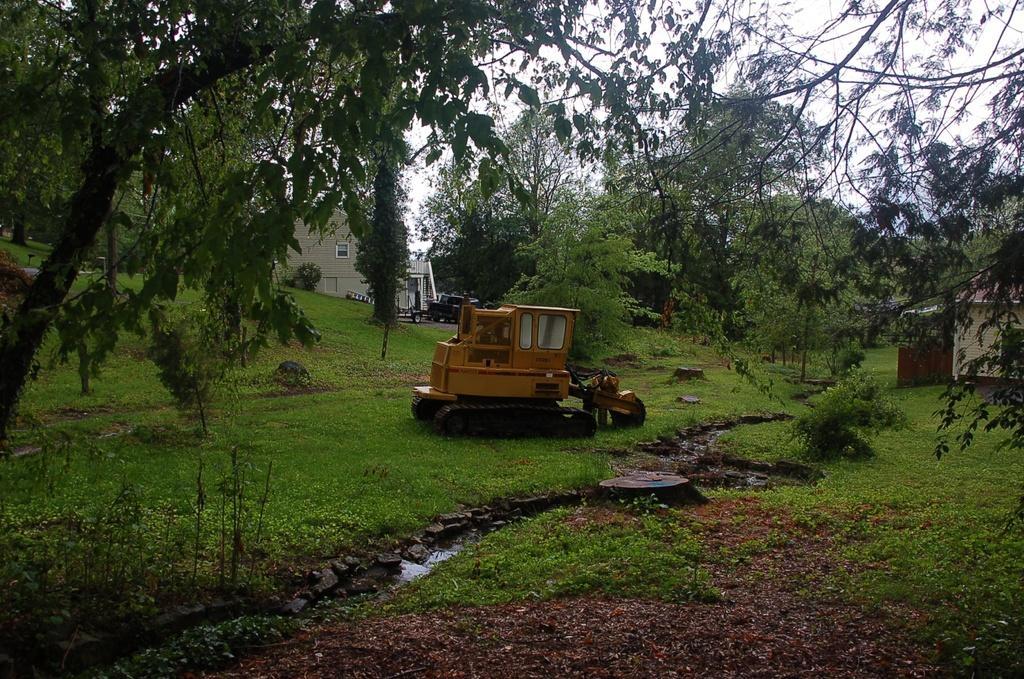Please provide a concise description of this image. There is one bulldozer on a grassy land as we can see in the middle of this image. There are some trees in the background. There is a building in the middle of this image and there is a sky at the top of this image. 